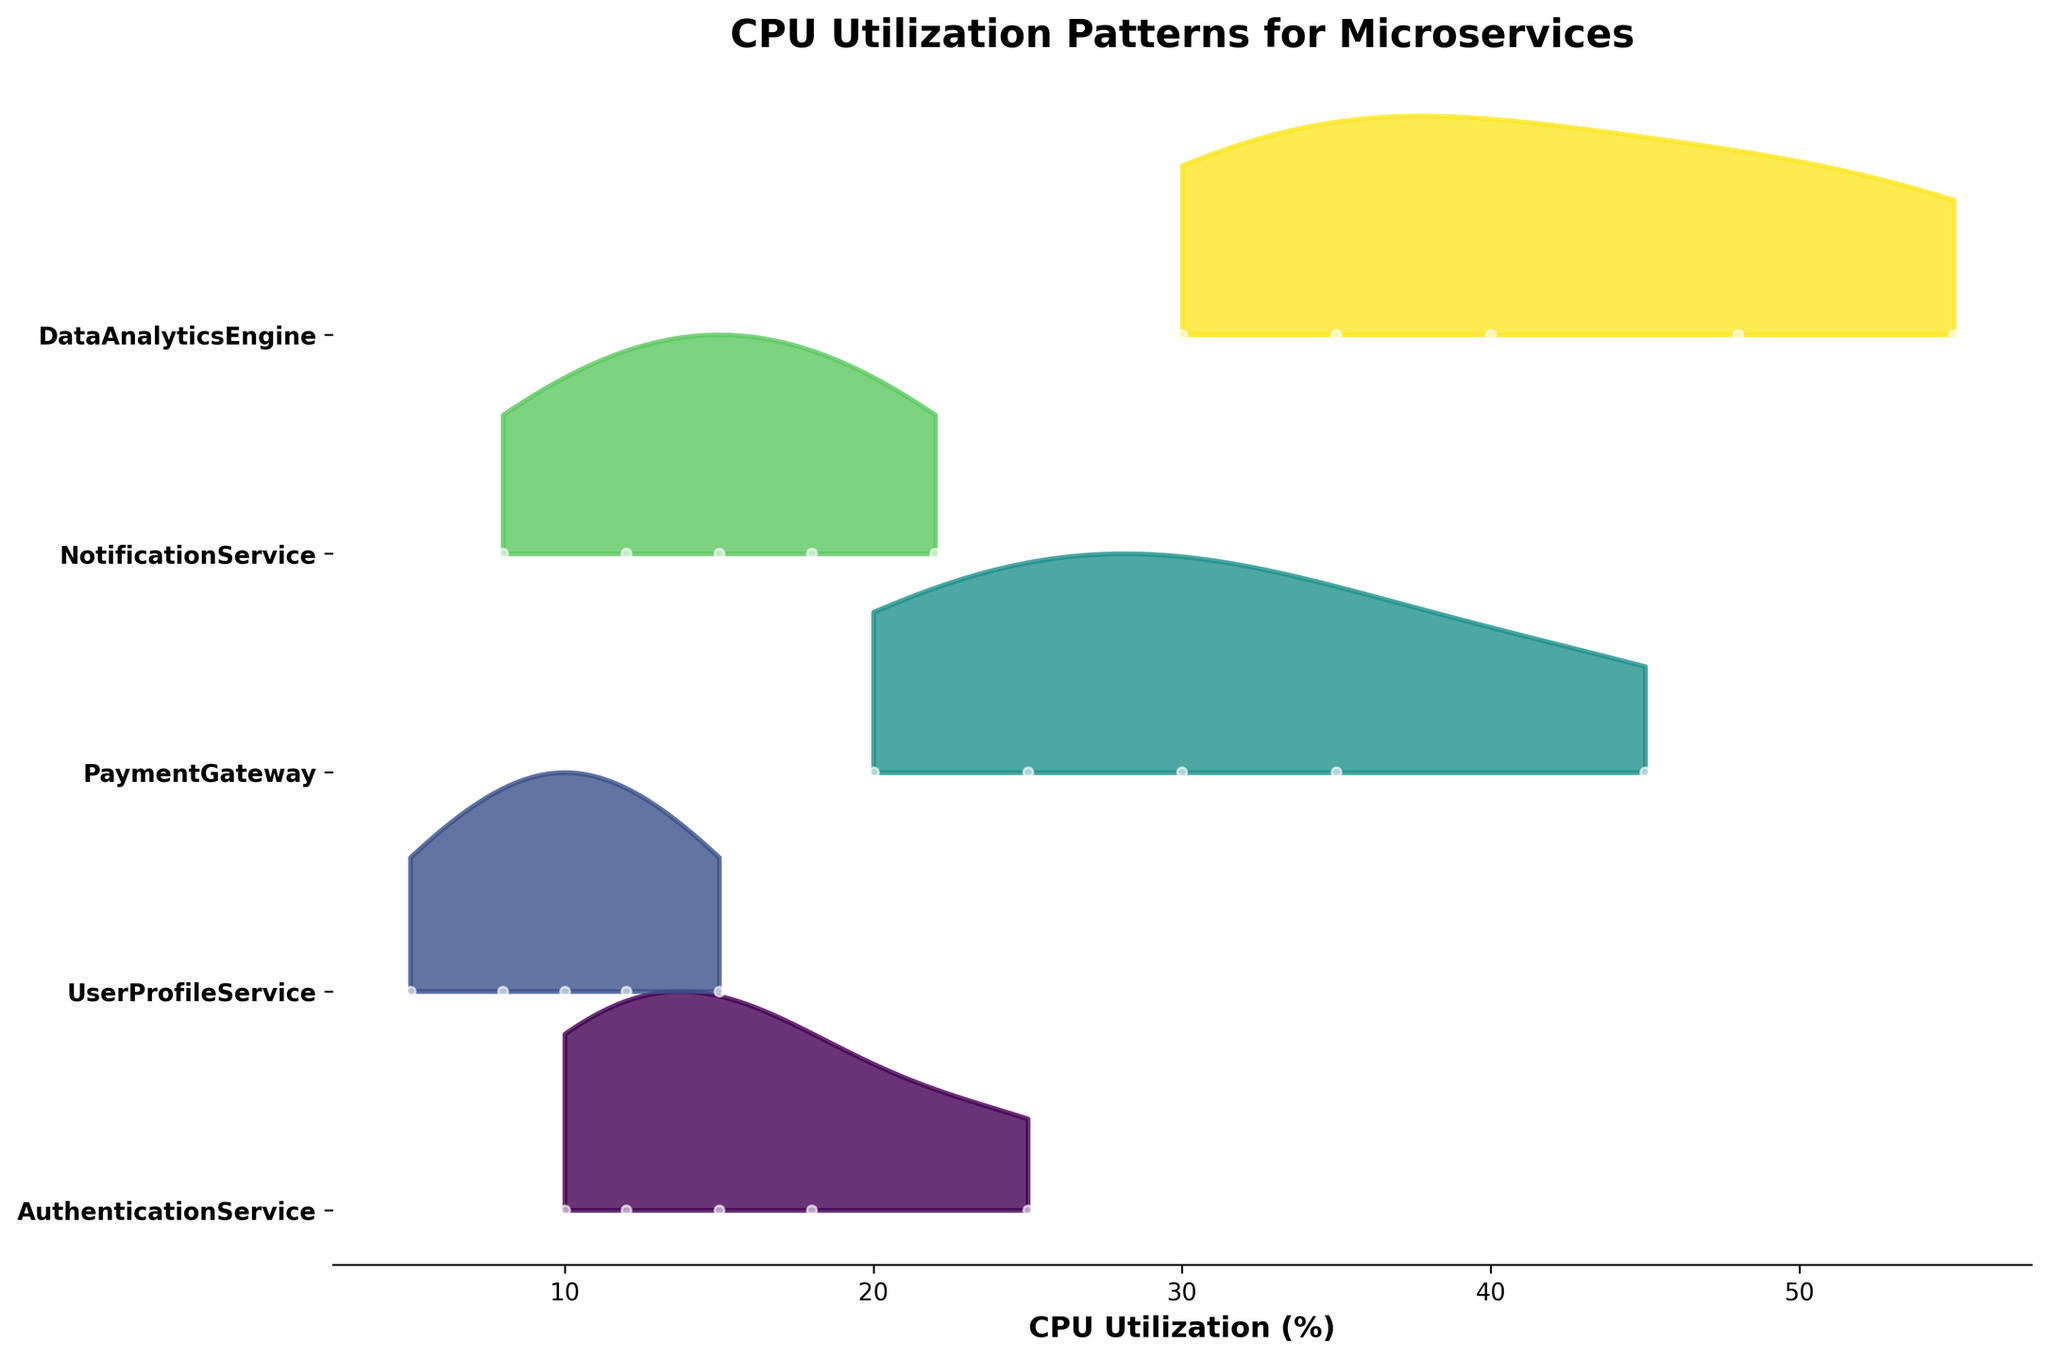What's the title of the figure? The title of a figure is usually located at the top. In this case, it reads "CPU Utilization Patterns for Microservices."
Answer: CPU Utilization Patterns for Microservices How many microservices are displayed in the figure? Count the unique labels on the y-axis, each representing a different microservice. There are five labels.
Answer: 5 Which microservice has the least variation in CPU utilization over time? The least variation would be indicated by the narrowest range or smallest spread in the ridgeline. Observing the slot widths, "UserProfileService" appears to have the smallest spread.
Answer: UserProfileService What is the maximum CPU utilization value for "DataAnalyticsEngine"? Identify the ridgeline for "DataAnalyticsEngine" and note its highest point. The maximum value reaches approximately 55%.
Answer: 55 Which microservice shows the highest peak in CPU utilization? Determine which microservice's ridgeline has the highest peak. "DataAnalyticsEngine" peaks at the highest point of roughly 55%.
Answer: DataAnalyticsEngine Compare the initial CPU utilization for "AuthenticationService" and "PaymentGateway". Which is higher? Look at the ridgeline for both services at timestamp 0. "PaymentGateway" starts higher with a value of 20% compared to "AuthenticationService" at 10%.
Answer: PaymentGateway What is the range of CPU utilization for "NotificationService"? Find the lowest and highest CPU utilization values within the ridgeline for "NotificationService." The range is from 8% to 22%.
Answer: 8%-22% Which two microservices have the most similar CPU utilization pattern? Compare the shapes and peak positions of the ridgelines. "AuthenticationService" and "NotificationService" appear to follow similar upward and downward patterns, especially noting their overlapping mid-range peaks.
Answer: AuthenticationService and NotificationService What is the mean CPU utilization for "PaymentGateway" across all timestamps? Sum the CPU utilization values for "PaymentGateway" (20 + 35 + 45 + 30 + 25) and divide by the number of data points (5). The average is 155/5 = 31%.
Answer: 31% Between "UserProfileService" and "NotificationService", which consistently utilizes more CPU? Compare their ridgelines visually across all timestamps. "NotificationService" generally maintains higher values across all points compared to "UserProfileService."
Answer: NotificationService 